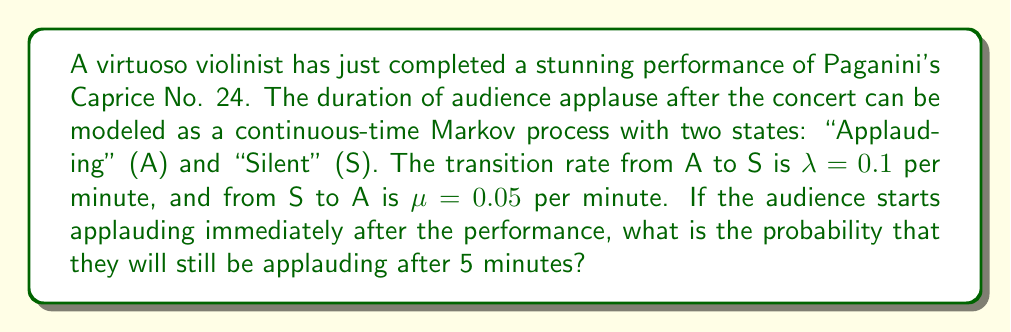Can you answer this question? To solve this problem, we'll use the continuous-time Markov chain model:

1) First, we need to set up the transition rate matrix Q:

   $$Q = \begin{bmatrix}
   -\lambda & \lambda \\
   \mu & -\mu
   \end{bmatrix} = \begin{bmatrix}
   -0.1 & 0.1 \\
   0.05 & -0.05
   \end{bmatrix}$$

2) The probability of being in state A at time t is given by:

   $$P_A(t) = \frac{\mu}{\lambda + \mu} + \frac{\lambda}{\lambda + \mu}e^{-(\lambda + \mu)t}$$

3) Substituting the values:

   $$P_A(t) = \frac{0.05}{0.1 + 0.05} + \frac{0.1}{0.1 + 0.05}e^{-(0.1 + 0.05)t}$$

4) Simplify:

   $$P_A(t) = \frac{1}{3} + \frac{2}{3}e^{-0.15t}$$

5) Now, we want to find $P_A(5)$:

   $$P_A(5) = \frac{1}{3} + \frac{2}{3}e^{-0.15 \cdot 5}$$

6) Calculate:

   $$P_A(5) = \frac{1}{3} + \frac{2}{3}e^{-0.75} \approx 0.5787$$

Therefore, the probability that the audience will still be applauding after 5 minutes is approximately 0.5787 or 57.87%.
Answer: 0.5787 